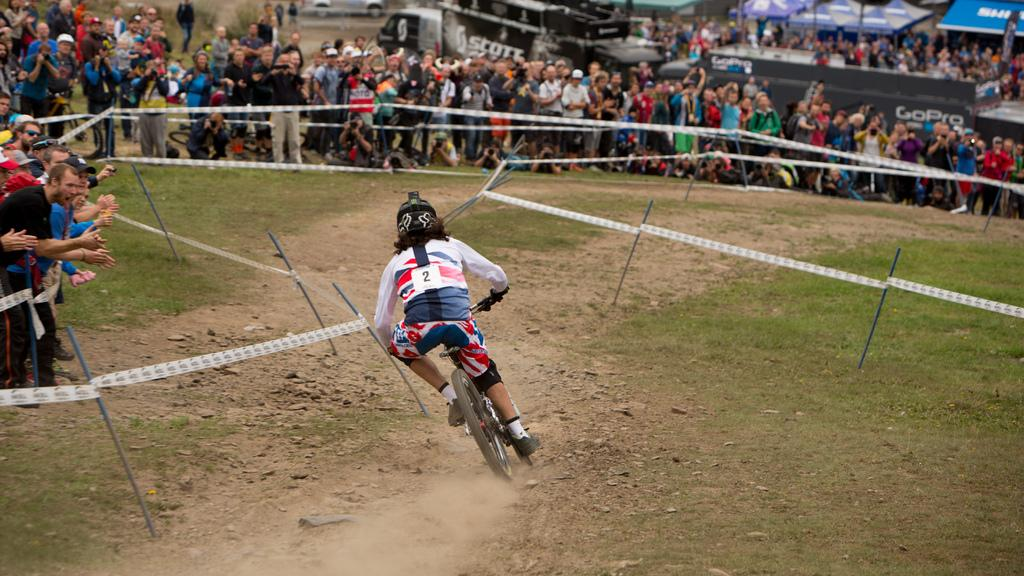<image>
Describe the image concisely. A person in a BMX race with the number 2 written on the back of their jersey. 